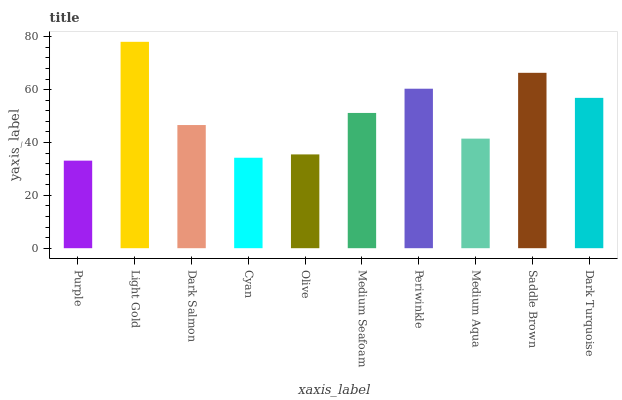Is Purple the minimum?
Answer yes or no. Yes. Is Light Gold the maximum?
Answer yes or no. Yes. Is Dark Salmon the minimum?
Answer yes or no. No. Is Dark Salmon the maximum?
Answer yes or no. No. Is Light Gold greater than Dark Salmon?
Answer yes or no. Yes. Is Dark Salmon less than Light Gold?
Answer yes or no. Yes. Is Dark Salmon greater than Light Gold?
Answer yes or no. No. Is Light Gold less than Dark Salmon?
Answer yes or no. No. Is Medium Seafoam the high median?
Answer yes or no. Yes. Is Dark Salmon the low median?
Answer yes or no. Yes. Is Light Gold the high median?
Answer yes or no. No. Is Dark Turquoise the low median?
Answer yes or no. No. 